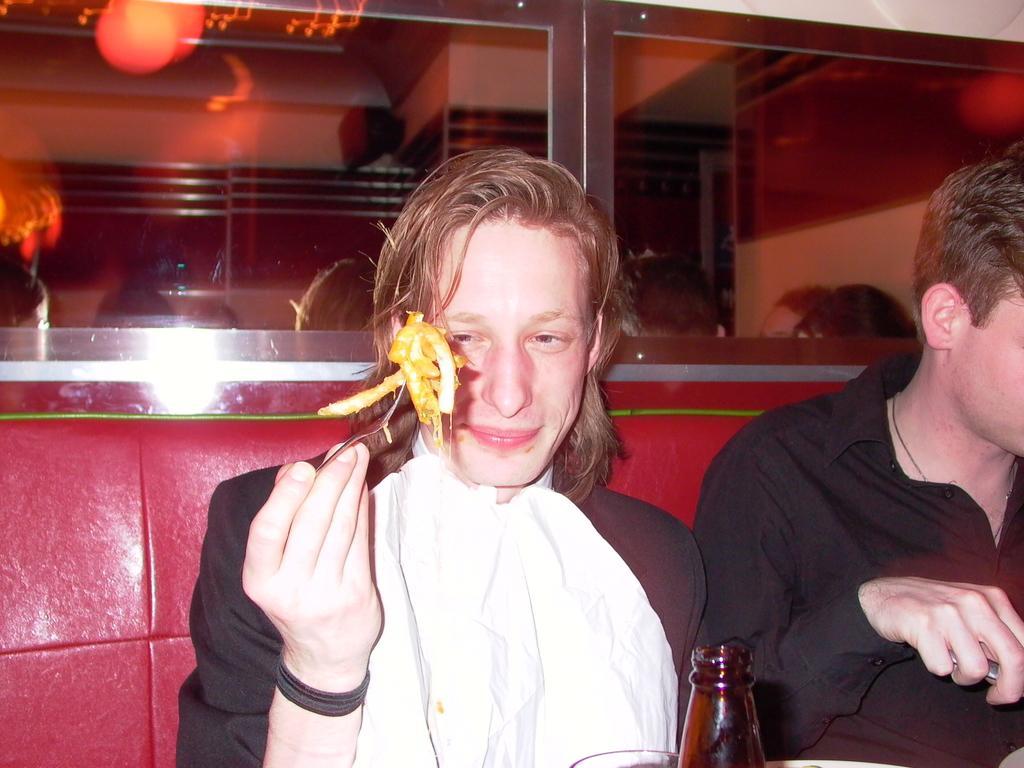In one or two sentences, can you explain what this image depicts? In this image there are two people, the boy who is left side of the image is holding a spoon in his right hand and there is a bottle and a glass on the table and the background of the image is red in color. 